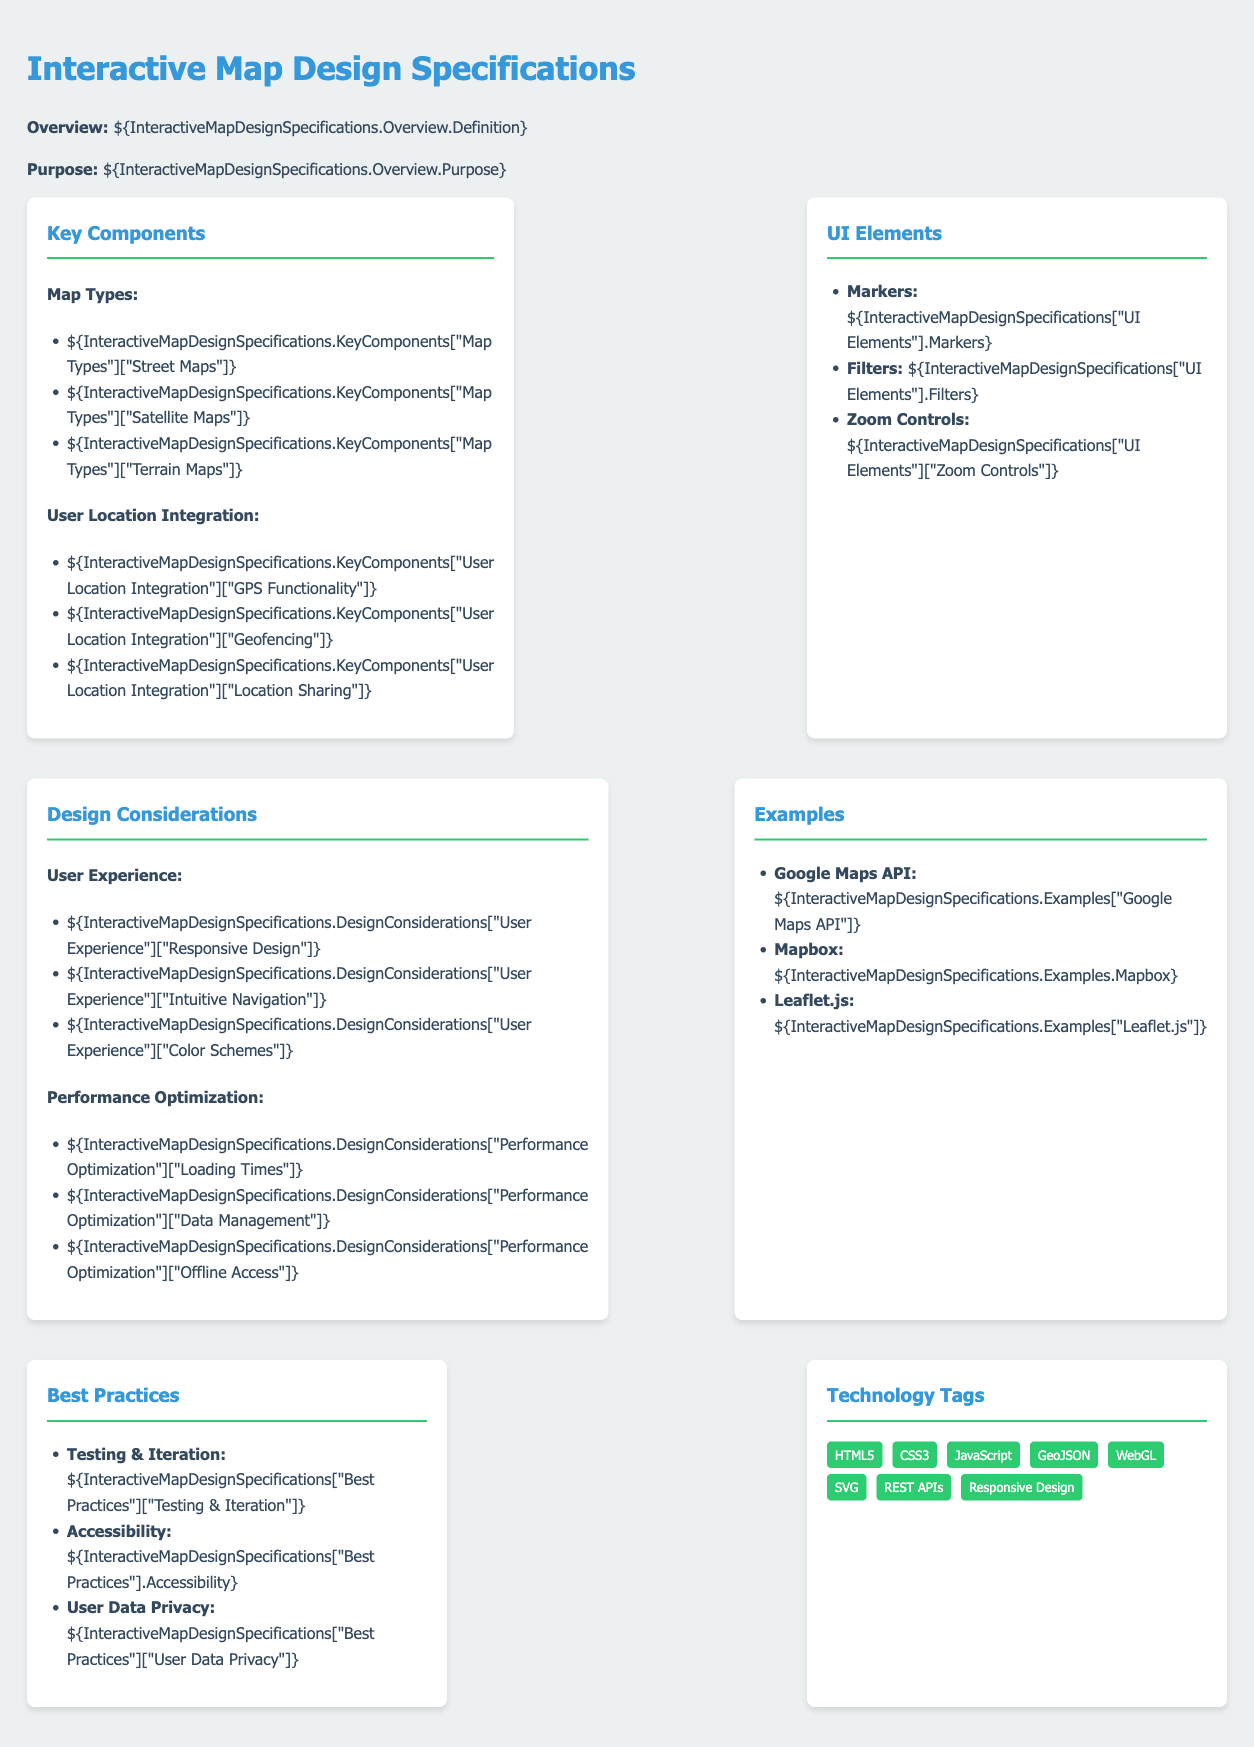What are the three map types listed? The document lists three map types under Key Components, which are Street Maps, Satellite Maps, and Terrain Maps.
Answer: Street Maps, Satellite Maps, Terrain Maps What functionality is included in User Location Integration? The User Location Integration section mentions GPS Functionality, Geofencing, and Location Sharing.
Answer: GPS Functionality, Geofencing, Location Sharing What is one design consideration for User Experience? The section on Design Considerations under User Experience includes Responsive Design, Intuitive Navigation, and Color Schemes.
Answer: Responsive Design What are the examples of map technologies provided? The Examples section lists Google Maps API, Mapbox, and Leaflet.js as examples of map technologies.
Answer: Google Maps API, Mapbox, Leaflet.js How many UI elements are mentioned? The UI Elements section lists three types: Markers, Filters, and Zoom Controls.
Answer: Three What does the tag "Accessibility" refer to? The Best Practices section includes a tag for Accessibility, which pertains to guidelines to make the app usable for all users.
Answer: Accessibility What is the primary color used in the design specifications? The document defines a primary color in its styles, which is specified in the CSS section as #3498db.
Answer: #3498db How does the menu enhance the interaction with the map? The menu's structured layout provides easy access to components, improving navigation and usability related to the interactive map.
Answer: Structured layout What type of design is emphasized for responsive design? The document specifically highlights Responsive Design as a key aspect for user experience in Design Considerations.
Answer: Responsive Design 